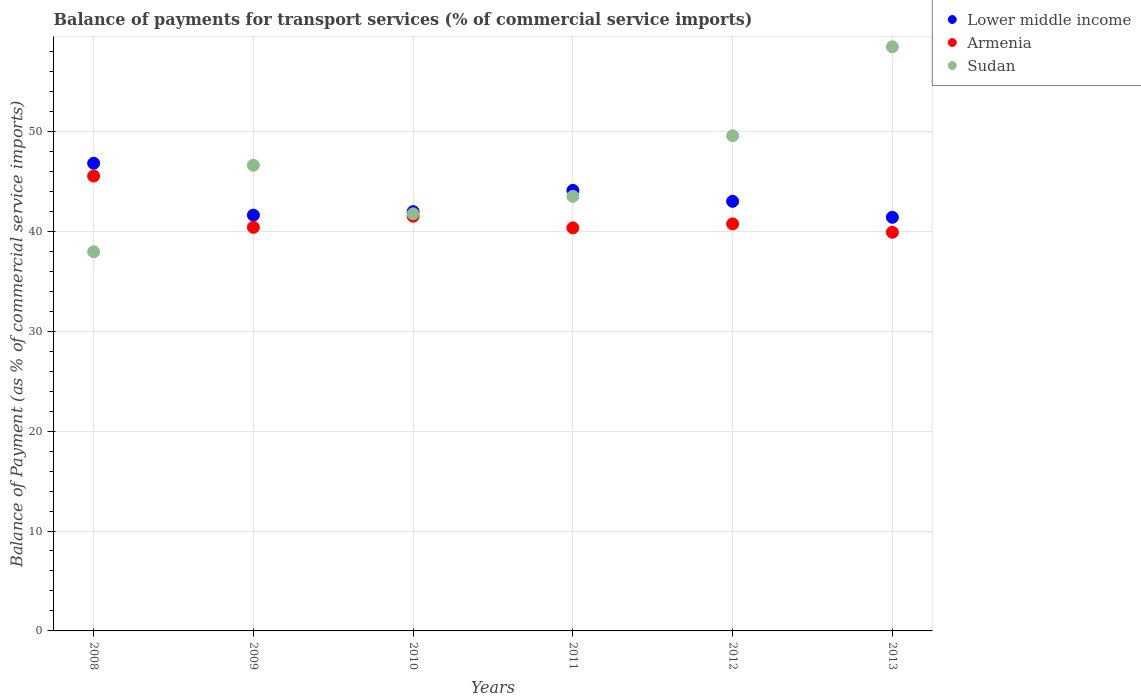What is the balance of payments for transport services in Armenia in 2011?
Provide a succinct answer. 40.34. Across all years, what is the maximum balance of payments for transport services in Lower middle income?
Ensure brevity in your answer.  46.8. Across all years, what is the minimum balance of payments for transport services in Lower middle income?
Give a very brief answer. 41.4. What is the total balance of payments for transport services in Sudan in the graph?
Keep it short and to the point. 277.81. What is the difference between the balance of payments for transport services in Lower middle income in 2009 and that in 2013?
Ensure brevity in your answer.  0.21. What is the difference between the balance of payments for transport services in Lower middle income in 2013 and the balance of payments for transport services in Armenia in 2012?
Offer a terse response. 0.66. What is the average balance of payments for transport services in Armenia per year?
Keep it short and to the point. 41.4. In the year 2013, what is the difference between the balance of payments for transport services in Armenia and balance of payments for transport services in Lower middle income?
Provide a succinct answer. -1.5. In how many years, is the balance of payments for transport services in Armenia greater than 16 %?
Make the answer very short. 6. What is the ratio of the balance of payments for transport services in Sudan in 2008 to that in 2012?
Keep it short and to the point. 0.77. Is the balance of payments for transport services in Lower middle income in 2008 less than that in 2013?
Ensure brevity in your answer.  No. What is the difference between the highest and the second highest balance of payments for transport services in Sudan?
Ensure brevity in your answer.  8.9. What is the difference between the highest and the lowest balance of payments for transport services in Sudan?
Give a very brief answer. 20.51. In how many years, is the balance of payments for transport services in Armenia greater than the average balance of payments for transport services in Armenia taken over all years?
Your answer should be very brief. 2. Does the balance of payments for transport services in Armenia monotonically increase over the years?
Your response must be concise. No. Is the balance of payments for transport services in Armenia strictly greater than the balance of payments for transport services in Sudan over the years?
Your answer should be compact. No. Is the balance of payments for transport services in Armenia strictly less than the balance of payments for transport services in Sudan over the years?
Give a very brief answer. No. How many dotlines are there?
Your answer should be compact. 3. Are the values on the major ticks of Y-axis written in scientific E-notation?
Keep it short and to the point. No. Where does the legend appear in the graph?
Keep it short and to the point. Top right. How many legend labels are there?
Your answer should be compact. 3. What is the title of the graph?
Provide a succinct answer. Balance of payments for transport services (% of commercial service imports). What is the label or title of the X-axis?
Give a very brief answer. Years. What is the label or title of the Y-axis?
Your response must be concise. Balance of Payment (as % of commercial service imports). What is the Balance of Payment (as % of commercial service imports) in Lower middle income in 2008?
Ensure brevity in your answer.  46.8. What is the Balance of Payment (as % of commercial service imports) of Armenia in 2008?
Ensure brevity in your answer.  45.52. What is the Balance of Payment (as % of commercial service imports) in Sudan in 2008?
Offer a very short reply. 37.95. What is the Balance of Payment (as % of commercial service imports) in Lower middle income in 2009?
Your answer should be very brief. 41.61. What is the Balance of Payment (as % of commercial service imports) in Armenia in 2009?
Ensure brevity in your answer.  40.39. What is the Balance of Payment (as % of commercial service imports) in Sudan in 2009?
Your answer should be compact. 46.6. What is the Balance of Payment (as % of commercial service imports) of Lower middle income in 2010?
Provide a succinct answer. 41.96. What is the Balance of Payment (as % of commercial service imports) of Armenia in 2010?
Your answer should be compact. 41.5. What is the Balance of Payment (as % of commercial service imports) of Sudan in 2010?
Your answer should be very brief. 41.74. What is the Balance of Payment (as % of commercial service imports) of Lower middle income in 2011?
Make the answer very short. 44.09. What is the Balance of Payment (as % of commercial service imports) of Armenia in 2011?
Keep it short and to the point. 40.34. What is the Balance of Payment (as % of commercial service imports) in Sudan in 2011?
Your answer should be very brief. 43.5. What is the Balance of Payment (as % of commercial service imports) in Lower middle income in 2012?
Offer a terse response. 42.99. What is the Balance of Payment (as % of commercial service imports) of Armenia in 2012?
Offer a very short reply. 40.73. What is the Balance of Payment (as % of commercial service imports) of Sudan in 2012?
Offer a terse response. 49.56. What is the Balance of Payment (as % of commercial service imports) of Lower middle income in 2013?
Offer a terse response. 41.4. What is the Balance of Payment (as % of commercial service imports) of Armenia in 2013?
Offer a terse response. 39.9. What is the Balance of Payment (as % of commercial service imports) of Sudan in 2013?
Offer a terse response. 58.46. Across all years, what is the maximum Balance of Payment (as % of commercial service imports) of Lower middle income?
Make the answer very short. 46.8. Across all years, what is the maximum Balance of Payment (as % of commercial service imports) of Armenia?
Your response must be concise. 45.52. Across all years, what is the maximum Balance of Payment (as % of commercial service imports) of Sudan?
Provide a succinct answer. 58.46. Across all years, what is the minimum Balance of Payment (as % of commercial service imports) in Lower middle income?
Provide a short and direct response. 41.4. Across all years, what is the minimum Balance of Payment (as % of commercial service imports) of Armenia?
Ensure brevity in your answer.  39.9. Across all years, what is the minimum Balance of Payment (as % of commercial service imports) of Sudan?
Give a very brief answer. 37.95. What is the total Balance of Payment (as % of commercial service imports) in Lower middle income in the graph?
Provide a short and direct response. 258.85. What is the total Balance of Payment (as % of commercial service imports) in Armenia in the graph?
Provide a short and direct response. 248.39. What is the total Balance of Payment (as % of commercial service imports) in Sudan in the graph?
Ensure brevity in your answer.  277.81. What is the difference between the Balance of Payment (as % of commercial service imports) of Lower middle income in 2008 and that in 2009?
Your answer should be very brief. 5.19. What is the difference between the Balance of Payment (as % of commercial service imports) in Armenia in 2008 and that in 2009?
Offer a terse response. 5.13. What is the difference between the Balance of Payment (as % of commercial service imports) of Sudan in 2008 and that in 2009?
Provide a succinct answer. -8.66. What is the difference between the Balance of Payment (as % of commercial service imports) of Lower middle income in 2008 and that in 2010?
Keep it short and to the point. 4.84. What is the difference between the Balance of Payment (as % of commercial service imports) in Armenia in 2008 and that in 2010?
Your response must be concise. 4.02. What is the difference between the Balance of Payment (as % of commercial service imports) in Sudan in 2008 and that in 2010?
Your response must be concise. -3.79. What is the difference between the Balance of Payment (as % of commercial service imports) of Lower middle income in 2008 and that in 2011?
Your answer should be very brief. 2.72. What is the difference between the Balance of Payment (as % of commercial service imports) of Armenia in 2008 and that in 2011?
Your answer should be very brief. 5.19. What is the difference between the Balance of Payment (as % of commercial service imports) in Sudan in 2008 and that in 2011?
Give a very brief answer. -5.55. What is the difference between the Balance of Payment (as % of commercial service imports) in Lower middle income in 2008 and that in 2012?
Make the answer very short. 3.81. What is the difference between the Balance of Payment (as % of commercial service imports) of Armenia in 2008 and that in 2012?
Keep it short and to the point. 4.79. What is the difference between the Balance of Payment (as % of commercial service imports) in Sudan in 2008 and that in 2012?
Your answer should be very brief. -11.61. What is the difference between the Balance of Payment (as % of commercial service imports) of Lower middle income in 2008 and that in 2013?
Offer a terse response. 5.41. What is the difference between the Balance of Payment (as % of commercial service imports) in Armenia in 2008 and that in 2013?
Your answer should be very brief. 5.62. What is the difference between the Balance of Payment (as % of commercial service imports) of Sudan in 2008 and that in 2013?
Offer a very short reply. -20.51. What is the difference between the Balance of Payment (as % of commercial service imports) of Lower middle income in 2009 and that in 2010?
Give a very brief answer. -0.35. What is the difference between the Balance of Payment (as % of commercial service imports) in Armenia in 2009 and that in 2010?
Offer a terse response. -1.11. What is the difference between the Balance of Payment (as % of commercial service imports) of Sudan in 2009 and that in 2010?
Offer a very short reply. 4.86. What is the difference between the Balance of Payment (as % of commercial service imports) in Lower middle income in 2009 and that in 2011?
Give a very brief answer. -2.47. What is the difference between the Balance of Payment (as % of commercial service imports) in Armenia in 2009 and that in 2011?
Offer a terse response. 0.06. What is the difference between the Balance of Payment (as % of commercial service imports) in Sudan in 2009 and that in 2011?
Make the answer very short. 3.11. What is the difference between the Balance of Payment (as % of commercial service imports) of Lower middle income in 2009 and that in 2012?
Ensure brevity in your answer.  -1.38. What is the difference between the Balance of Payment (as % of commercial service imports) of Armenia in 2009 and that in 2012?
Your answer should be very brief. -0.34. What is the difference between the Balance of Payment (as % of commercial service imports) of Sudan in 2009 and that in 2012?
Offer a terse response. -2.95. What is the difference between the Balance of Payment (as % of commercial service imports) of Lower middle income in 2009 and that in 2013?
Ensure brevity in your answer.  0.21. What is the difference between the Balance of Payment (as % of commercial service imports) of Armenia in 2009 and that in 2013?
Your answer should be very brief. 0.49. What is the difference between the Balance of Payment (as % of commercial service imports) of Sudan in 2009 and that in 2013?
Provide a succinct answer. -11.85. What is the difference between the Balance of Payment (as % of commercial service imports) of Lower middle income in 2010 and that in 2011?
Provide a succinct answer. -2.12. What is the difference between the Balance of Payment (as % of commercial service imports) in Armenia in 2010 and that in 2011?
Make the answer very short. 1.17. What is the difference between the Balance of Payment (as % of commercial service imports) of Sudan in 2010 and that in 2011?
Your response must be concise. -1.75. What is the difference between the Balance of Payment (as % of commercial service imports) of Lower middle income in 2010 and that in 2012?
Offer a very short reply. -1.03. What is the difference between the Balance of Payment (as % of commercial service imports) in Armenia in 2010 and that in 2012?
Keep it short and to the point. 0.77. What is the difference between the Balance of Payment (as % of commercial service imports) of Sudan in 2010 and that in 2012?
Provide a short and direct response. -7.81. What is the difference between the Balance of Payment (as % of commercial service imports) in Lower middle income in 2010 and that in 2013?
Keep it short and to the point. 0.56. What is the difference between the Balance of Payment (as % of commercial service imports) in Armenia in 2010 and that in 2013?
Provide a short and direct response. 1.6. What is the difference between the Balance of Payment (as % of commercial service imports) of Sudan in 2010 and that in 2013?
Your answer should be very brief. -16.71. What is the difference between the Balance of Payment (as % of commercial service imports) of Lower middle income in 2011 and that in 2012?
Offer a very short reply. 1.09. What is the difference between the Balance of Payment (as % of commercial service imports) of Armenia in 2011 and that in 2012?
Provide a short and direct response. -0.4. What is the difference between the Balance of Payment (as % of commercial service imports) of Sudan in 2011 and that in 2012?
Ensure brevity in your answer.  -6.06. What is the difference between the Balance of Payment (as % of commercial service imports) in Lower middle income in 2011 and that in 2013?
Offer a very short reply. 2.69. What is the difference between the Balance of Payment (as % of commercial service imports) in Armenia in 2011 and that in 2013?
Provide a succinct answer. 0.44. What is the difference between the Balance of Payment (as % of commercial service imports) in Sudan in 2011 and that in 2013?
Give a very brief answer. -14.96. What is the difference between the Balance of Payment (as % of commercial service imports) in Lower middle income in 2012 and that in 2013?
Keep it short and to the point. 1.6. What is the difference between the Balance of Payment (as % of commercial service imports) in Armenia in 2012 and that in 2013?
Ensure brevity in your answer.  0.83. What is the difference between the Balance of Payment (as % of commercial service imports) of Sudan in 2012 and that in 2013?
Your response must be concise. -8.9. What is the difference between the Balance of Payment (as % of commercial service imports) in Lower middle income in 2008 and the Balance of Payment (as % of commercial service imports) in Armenia in 2009?
Offer a very short reply. 6.41. What is the difference between the Balance of Payment (as % of commercial service imports) of Lower middle income in 2008 and the Balance of Payment (as % of commercial service imports) of Sudan in 2009?
Offer a very short reply. 0.2. What is the difference between the Balance of Payment (as % of commercial service imports) in Armenia in 2008 and the Balance of Payment (as % of commercial service imports) in Sudan in 2009?
Your answer should be compact. -1.08. What is the difference between the Balance of Payment (as % of commercial service imports) of Lower middle income in 2008 and the Balance of Payment (as % of commercial service imports) of Armenia in 2010?
Give a very brief answer. 5.3. What is the difference between the Balance of Payment (as % of commercial service imports) in Lower middle income in 2008 and the Balance of Payment (as % of commercial service imports) in Sudan in 2010?
Make the answer very short. 5.06. What is the difference between the Balance of Payment (as % of commercial service imports) in Armenia in 2008 and the Balance of Payment (as % of commercial service imports) in Sudan in 2010?
Your response must be concise. 3.78. What is the difference between the Balance of Payment (as % of commercial service imports) of Lower middle income in 2008 and the Balance of Payment (as % of commercial service imports) of Armenia in 2011?
Keep it short and to the point. 6.47. What is the difference between the Balance of Payment (as % of commercial service imports) of Lower middle income in 2008 and the Balance of Payment (as % of commercial service imports) of Sudan in 2011?
Provide a succinct answer. 3.31. What is the difference between the Balance of Payment (as % of commercial service imports) of Armenia in 2008 and the Balance of Payment (as % of commercial service imports) of Sudan in 2011?
Offer a very short reply. 2.03. What is the difference between the Balance of Payment (as % of commercial service imports) of Lower middle income in 2008 and the Balance of Payment (as % of commercial service imports) of Armenia in 2012?
Provide a short and direct response. 6.07. What is the difference between the Balance of Payment (as % of commercial service imports) in Lower middle income in 2008 and the Balance of Payment (as % of commercial service imports) in Sudan in 2012?
Provide a short and direct response. -2.75. What is the difference between the Balance of Payment (as % of commercial service imports) of Armenia in 2008 and the Balance of Payment (as % of commercial service imports) of Sudan in 2012?
Your response must be concise. -4.04. What is the difference between the Balance of Payment (as % of commercial service imports) in Lower middle income in 2008 and the Balance of Payment (as % of commercial service imports) in Armenia in 2013?
Your answer should be very brief. 6.9. What is the difference between the Balance of Payment (as % of commercial service imports) of Lower middle income in 2008 and the Balance of Payment (as % of commercial service imports) of Sudan in 2013?
Your answer should be compact. -11.65. What is the difference between the Balance of Payment (as % of commercial service imports) in Armenia in 2008 and the Balance of Payment (as % of commercial service imports) in Sudan in 2013?
Your response must be concise. -12.93. What is the difference between the Balance of Payment (as % of commercial service imports) of Lower middle income in 2009 and the Balance of Payment (as % of commercial service imports) of Armenia in 2010?
Make the answer very short. 0.11. What is the difference between the Balance of Payment (as % of commercial service imports) in Lower middle income in 2009 and the Balance of Payment (as % of commercial service imports) in Sudan in 2010?
Offer a terse response. -0.13. What is the difference between the Balance of Payment (as % of commercial service imports) of Armenia in 2009 and the Balance of Payment (as % of commercial service imports) of Sudan in 2010?
Your response must be concise. -1.35. What is the difference between the Balance of Payment (as % of commercial service imports) in Lower middle income in 2009 and the Balance of Payment (as % of commercial service imports) in Armenia in 2011?
Provide a succinct answer. 1.27. What is the difference between the Balance of Payment (as % of commercial service imports) in Lower middle income in 2009 and the Balance of Payment (as % of commercial service imports) in Sudan in 2011?
Provide a succinct answer. -1.88. What is the difference between the Balance of Payment (as % of commercial service imports) of Armenia in 2009 and the Balance of Payment (as % of commercial service imports) of Sudan in 2011?
Give a very brief answer. -3.1. What is the difference between the Balance of Payment (as % of commercial service imports) of Lower middle income in 2009 and the Balance of Payment (as % of commercial service imports) of Armenia in 2012?
Your answer should be compact. 0.88. What is the difference between the Balance of Payment (as % of commercial service imports) of Lower middle income in 2009 and the Balance of Payment (as % of commercial service imports) of Sudan in 2012?
Keep it short and to the point. -7.95. What is the difference between the Balance of Payment (as % of commercial service imports) of Armenia in 2009 and the Balance of Payment (as % of commercial service imports) of Sudan in 2012?
Your answer should be very brief. -9.17. What is the difference between the Balance of Payment (as % of commercial service imports) of Lower middle income in 2009 and the Balance of Payment (as % of commercial service imports) of Armenia in 2013?
Offer a terse response. 1.71. What is the difference between the Balance of Payment (as % of commercial service imports) in Lower middle income in 2009 and the Balance of Payment (as % of commercial service imports) in Sudan in 2013?
Make the answer very short. -16.85. What is the difference between the Balance of Payment (as % of commercial service imports) in Armenia in 2009 and the Balance of Payment (as % of commercial service imports) in Sudan in 2013?
Keep it short and to the point. -18.07. What is the difference between the Balance of Payment (as % of commercial service imports) of Lower middle income in 2010 and the Balance of Payment (as % of commercial service imports) of Armenia in 2011?
Keep it short and to the point. 1.63. What is the difference between the Balance of Payment (as % of commercial service imports) of Lower middle income in 2010 and the Balance of Payment (as % of commercial service imports) of Sudan in 2011?
Provide a short and direct response. -1.53. What is the difference between the Balance of Payment (as % of commercial service imports) of Armenia in 2010 and the Balance of Payment (as % of commercial service imports) of Sudan in 2011?
Your answer should be very brief. -1.99. What is the difference between the Balance of Payment (as % of commercial service imports) of Lower middle income in 2010 and the Balance of Payment (as % of commercial service imports) of Armenia in 2012?
Your answer should be compact. 1.23. What is the difference between the Balance of Payment (as % of commercial service imports) in Lower middle income in 2010 and the Balance of Payment (as % of commercial service imports) in Sudan in 2012?
Offer a very short reply. -7.6. What is the difference between the Balance of Payment (as % of commercial service imports) of Armenia in 2010 and the Balance of Payment (as % of commercial service imports) of Sudan in 2012?
Offer a terse response. -8.06. What is the difference between the Balance of Payment (as % of commercial service imports) of Lower middle income in 2010 and the Balance of Payment (as % of commercial service imports) of Armenia in 2013?
Ensure brevity in your answer.  2.06. What is the difference between the Balance of Payment (as % of commercial service imports) in Lower middle income in 2010 and the Balance of Payment (as % of commercial service imports) in Sudan in 2013?
Provide a succinct answer. -16.49. What is the difference between the Balance of Payment (as % of commercial service imports) in Armenia in 2010 and the Balance of Payment (as % of commercial service imports) in Sudan in 2013?
Your answer should be very brief. -16.95. What is the difference between the Balance of Payment (as % of commercial service imports) of Lower middle income in 2011 and the Balance of Payment (as % of commercial service imports) of Armenia in 2012?
Ensure brevity in your answer.  3.35. What is the difference between the Balance of Payment (as % of commercial service imports) of Lower middle income in 2011 and the Balance of Payment (as % of commercial service imports) of Sudan in 2012?
Provide a succinct answer. -5.47. What is the difference between the Balance of Payment (as % of commercial service imports) in Armenia in 2011 and the Balance of Payment (as % of commercial service imports) in Sudan in 2012?
Your answer should be compact. -9.22. What is the difference between the Balance of Payment (as % of commercial service imports) in Lower middle income in 2011 and the Balance of Payment (as % of commercial service imports) in Armenia in 2013?
Your answer should be compact. 4.19. What is the difference between the Balance of Payment (as % of commercial service imports) of Lower middle income in 2011 and the Balance of Payment (as % of commercial service imports) of Sudan in 2013?
Provide a short and direct response. -14.37. What is the difference between the Balance of Payment (as % of commercial service imports) in Armenia in 2011 and the Balance of Payment (as % of commercial service imports) in Sudan in 2013?
Your response must be concise. -18.12. What is the difference between the Balance of Payment (as % of commercial service imports) in Lower middle income in 2012 and the Balance of Payment (as % of commercial service imports) in Armenia in 2013?
Offer a very short reply. 3.1. What is the difference between the Balance of Payment (as % of commercial service imports) of Lower middle income in 2012 and the Balance of Payment (as % of commercial service imports) of Sudan in 2013?
Offer a terse response. -15.46. What is the difference between the Balance of Payment (as % of commercial service imports) in Armenia in 2012 and the Balance of Payment (as % of commercial service imports) in Sudan in 2013?
Give a very brief answer. -17.72. What is the average Balance of Payment (as % of commercial service imports) of Lower middle income per year?
Offer a terse response. 43.14. What is the average Balance of Payment (as % of commercial service imports) in Armenia per year?
Provide a short and direct response. 41.4. What is the average Balance of Payment (as % of commercial service imports) in Sudan per year?
Offer a terse response. 46.3. In the year 2008, what is the difference between the Balance of Payment (as % of commercial service imports) of Lower middle income and Balance of Payment (as % of commercial service imports) of Armenia?
Offer a terse response. 1.28. In the year 2008, what is the difference between the Balance of Payment (as % of commercial service imports) of Lower middle income and Balance of Payment (as % of commercial service imports) of Sudan?
Provide a short and direct response. 8.86. In the year 2008, what is the difference between the Balance of Payment (as % of commercial service imports) of Armenia and Balance of Payment (as % of commercial service imports) of Sudan?
Ensure brevity in your answer.  7.57. In the year 2009, what is the difference between the Balance of Payment (as % of commercial service imports) of Lower middle income and Balance of Payment (as % of commercial service imports) of Armenia?
Keep it short and to the point. 1.22. In the year 2009, what is the difference between the Balance of Payment (as % of commercial service imports) of Lower middle income and Balance of Payment (as % of commercial service imports) of Sudan?
Your answer should be very brief. -4.99. In the year 2009, what is the difference between the Balance of Payment (as % of commercial service imports) in Armenia and Balance of Payment (as % of commercial service imports) in Sudan?
Give a very brief answer. -6.21. In the year 2010, what is the difference between the Balance of Payment (as % of commercial service imports) of Lower middle income and Balance of Payment (as % of commercial service imports) of Armenia?
Offer a very short reply. 0.46. In the year 2010, what is the difference between the Balance of Payment (as % of commercial service imports) of Lower middle income and Balance of Payment (as % of commercial service imports) of Sudan?
Your answer should be compact. 0.22. In the year 2010, what is the difference between the Balance of Payment (as % of commercial service imports) of Armenia and Balance of Payment (as % of commercial service imports) of Sudan?
Your answer should be very brief. -0.24. In the year 2011, what is the difference between the Balance of Payment (as % of commercial service imports) of Lower middle income and Balance of Payment (as % of commercial service imports) of Armenia?
Your answer should be compact. 3.75. In the year 2011, what is the difference between the Balance of Payment (as % of commercial service imports) of Lower middle income and Balance of Payment (as % of commercial service imports) of Sudan?
Keep it short and to the point. 0.59. In the year 2011, what is the difference between the Balance of Payment (as % of commercial service imports) of Armenia and Balance of Payment (as % of commercial service imports) of Sudan?
Provide a short and direct response. -3.16. In the year 2012, what is the difference between the Balance of Payment (as % of commercial service imports) of Lower middle income and Balance of Payment (as % of commercial service imports) of Armenia?
Provide a short and direct response. 2.26. In the year 2012, what is the difference between the Balance of Payment (as % of commercial service imports) in Lower middle income and Balance of Payment (as % of commercial service imports) in Sudan?
Offer a terse response. -6.56. In the year 2012, what is the difference between the Balance of Payment (as % of commercial service imports) in Armenia and Balance of Payment (as % of commercial service imports) in Sudan?
Your answer should be very brief. -8.82. In the year 2013, what is the difference between the Balance of Payment (as % of commercial service imports) of Lower middle income and Balance of Payment (as % of commercial service imports) of Armenia?
Give a very brief answer. 1.5. In the year 2013, what is the difference between the Balance of Payment (as % of commercial service imports) in Lower middle income and Balance of Payment (as % of commercial service imports) in Sudan?
Offer a terse response. -17.06. In the year 2013, what is the difference between the Balance of Payment (as % of commercial service imports) of Armenia and Balance of Payment (as % of commercial service imports) of Sudan?
Offer a terse response. -18.56. What is the ratio of the Balance of Payment (as % of commercial service imports) of Lower middle income in 2008 to that in 2009?
Provide a short and direct response. 1.12. What is the ratio of the Balance of Payment (as % of commercial service imports) of Armenia in 2008 to that in 2009?
Offer a very short reply. 1.13. What is the ratio of the Balance of Payment (as % of commercial service imports) in Sudan in 2008 to that in 2009?
Ensure brevity in your answer.  0.81. What is the ratio of the Balance of Payment (as % of commercial service imports) in Lower middle income in 2008 to that in 2010?
Offer a very short reply. 1.12. What is the ratio of the Balance of Payment (as % of commercial service imports) in Armenia in 2008 to that in 2010?
Give a very brief answer. 1.1. What is the ratio of the Balance of Payment (as % of commercial service imports) of Lower middle income in 2008 to that in 2011?
Offer a very short reply. 1.06. What is the ratio of the Balance of Payment (as % of commercial service imports) of Armenia in 2008 to that in 2011?
Give a very brief answer. 1.13. What is the ratio of the Balance of Payment (as % of commercial service imports) of Sudan in 2008 to that in 2011?
Ensure brevity in your answer.  0.87. What is the ratio of the Balance of Payment (as % of commercial service imports) of Lower middle income in 2008 to that in 2012?
Keep it short and to the point. 1.09. What is the ratio of the Balance of Payment (as % of commercial service imports) of Armenia in 2008 to that in 2012?
Offer a terse response. 1.12. What is the ratio of the Balance of Payment (as % of commercial service imports) of Sudan in 2008 to that in 2012?
Keep it short and to the point. 0.77. What is the ratio of the Balance of Payment (as % of commercial service imports) of Lower middle income in 2008 to that in 2013?
Ensure brevity in your answer.  1.13. What is the ratio of the Balance of Payment (as % of commercial service imports) of Armenia in 2008 to that in 2013?
Your answer should be compact. 1.14. What is the ratio of the Balance of Payment (as % of commercial service imports) in Sudan in 2008 to that in 2013?
Provide a succinct answer. 0.65. What is the ratio of the Balance of Payment (as % of commercial service imports) in Armenia in 2009 to that in 2010?
Your response must be concise. 0.97. What is the ratio of the Balance of Payment (as % of commercial service imports) of Sudan in 2009 to that in 2010?
Offer a very short reply. 1.12. What is the ratio of the Balance of Payment (as % of commercial service imports) of Lower middle income in 2009 to that in 2011?
Ensure brevity in your answer.  0.94. What is the ratio of the Balance of Payment (as % of commercial service imports) in Sudan in 2009 to that in 2011?
Ensure brevity in your answer.  1.07. What is the ratio of the Balance of Payment (as % of commercial service imports) in Lower middle income in 2009 to that in 2012?
Make the answer very short. 0.97. What is the ratio of the Balance of Payment (as % of commercial service imports) in Sudan in 2009 to that in 2012?
Your answer should be compact. 0.94. What is the ratio of the Balance of Payment (as % of commercial service imports) in Armenia in 2009 to that in 2013?
Make the answer very short. 1.01. What is the ratio of the Balance of Payment (as % of commercial service imports) of Sudan in 2009 to that in 2013?
Your answer should be compact. 0.8. What is the ratio of the Balance of Payment (as % of commercial service imports) in Lower middle income in 2010 to that in 2011?
Offer a very short reply. 0.95. What is the ratio of the Balance of Payment (as % of commercial service imports) in Armenia in 2010 to that in 2011?
Your response must be concise. 1.03. What is the ratio of the Balance of Payment (as % of commercial service imports) of Sudan in 2010 to that in 2011?
Offer a very short reply. 0.96. What is the ratio of the Balance of Payment (as % of commercial service imports) of Lower middle income in 2010 to that in 2012?
Your answer should be compact. 0.98. What is the ratio of the Balance of Payment (as % of commercial service imports) of Armenia in 2010 to that in 2012?
Offer a very short reply. 1.02. What is the ratio of the Balance of Payment (as % of commercial service imports) in Sudan in 2010 to that in 2012?
Give a very brief answer. 0.84. What is the ratio of the Balance of Payment (as % of commercial service imports) in Lower middle income in 2010 to that in 2013?
Your answer should be very brief. 1.01. What is the ratio of the Balance of Payment (as % of commercial service imports) in Armenia in 2010 to that in 2013?
Ensure brevity in your answer.  1.04. What is the ratio of the Balance of Payment (as % of commercial service imports) in Sudan in 2010 to that in 2013?
Give a very brief answer. 0.71. What is the ratio of the Balance of Payment (as % of commercial service imports) of Lower middle income in 2011 to that in 2012?
Your response must be concise. 1.03. What is the ratio of the Balance of Payment (as % of commercial service imports) of Armenia in 2011 to that in 2012?
Ensure brevity in your answer.  0.99. What is the ratio of the Balance of Payment (as % of commercial service imports) in Sudan in 2011 to that in 2012?
Offer a very short reply. 0.88. What is the ratio of the Balance of Payment (as % of commercial service imports) of Lower middle income in 2011 to that in 2013?
Give a very brief answer. 1.06. What is the ratio of the Balance of Payment (as % of commercial service imports) of Sudan in 2011 to that in 2013?
Your response must be concise. 0.74. What is the ratio of the Balance of Payment (as % of commercial service imports) in Lower middle income in 2012 to that in 2013?
Give a very brief answer. 1.04. What is the ratio of the Balance of Payment (as % of commercial service imports) of Armenia in 2012 to that in 2013?
Your answer should be very brief. 1.02. What is the ratio of the Balance of Payment (as % of commercial service imports) of Sudan in 2012 to that in 2013?
Make the answer very short. 0.85. What is the difference between the highest and the second highest Balance of Payment (as % of commercial service imports) of Lower middle income?
Keep it short and to the point. 2.72. What is the difference between the highest and the second highest Balance of Payment (as % of commercial service imports) in Armenia?
Give a very brief answer. 4.02. What is the difference between the highest and the second highest Balance of Payment (as % of commercial service imports) in Sudan?
Make the answer very short. 8.9. What is the difference between the highest and the lowest Balance of Payment (as % of commercial service imports) of Lower middle income?
Ensure brevity in your answer.  5.41. What is the difference between the highest and the lowest Balance of Payment (as % of commercial service imports) in Armenia?
Your answer should be very brief. 5.62. What is the difference between the highest and the lowest Balance of Payment (as % of commercial service imports) of Sudan?
Offer a very short reply. 20.51. 